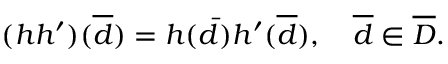Convert formula to latex. <formula><loc_0><loc_0><loc_500><loc_500>( h h ^ { \prime } ) ( \overline { d } ) = h ( \bar { d } ) h ^ { \prime } ( \overline { d } ) , \quad \overline { d } \in \overline { D } .</formula> 